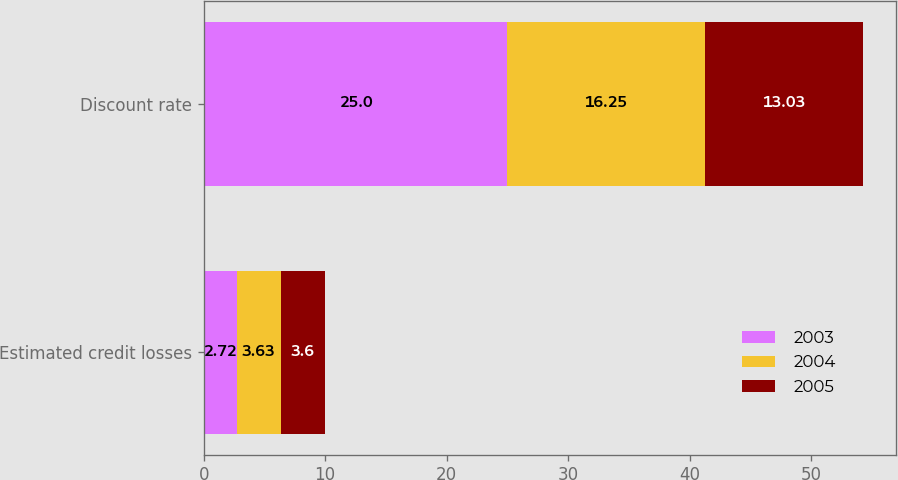Convert chart. <chart><loc_0><loc_0><loc_500><loc_500><stacked_bar_chart><ecel><fcel>Estimated credit losses<fcel>Discount rate<nl><fcel>2003<fcel>2.72<fcel>25<nl><fcel>2004<fcel>3.63<fcel>16.25<nl><fcel>2005<fcel>3.6<fcel>13.03<nl></chart> 